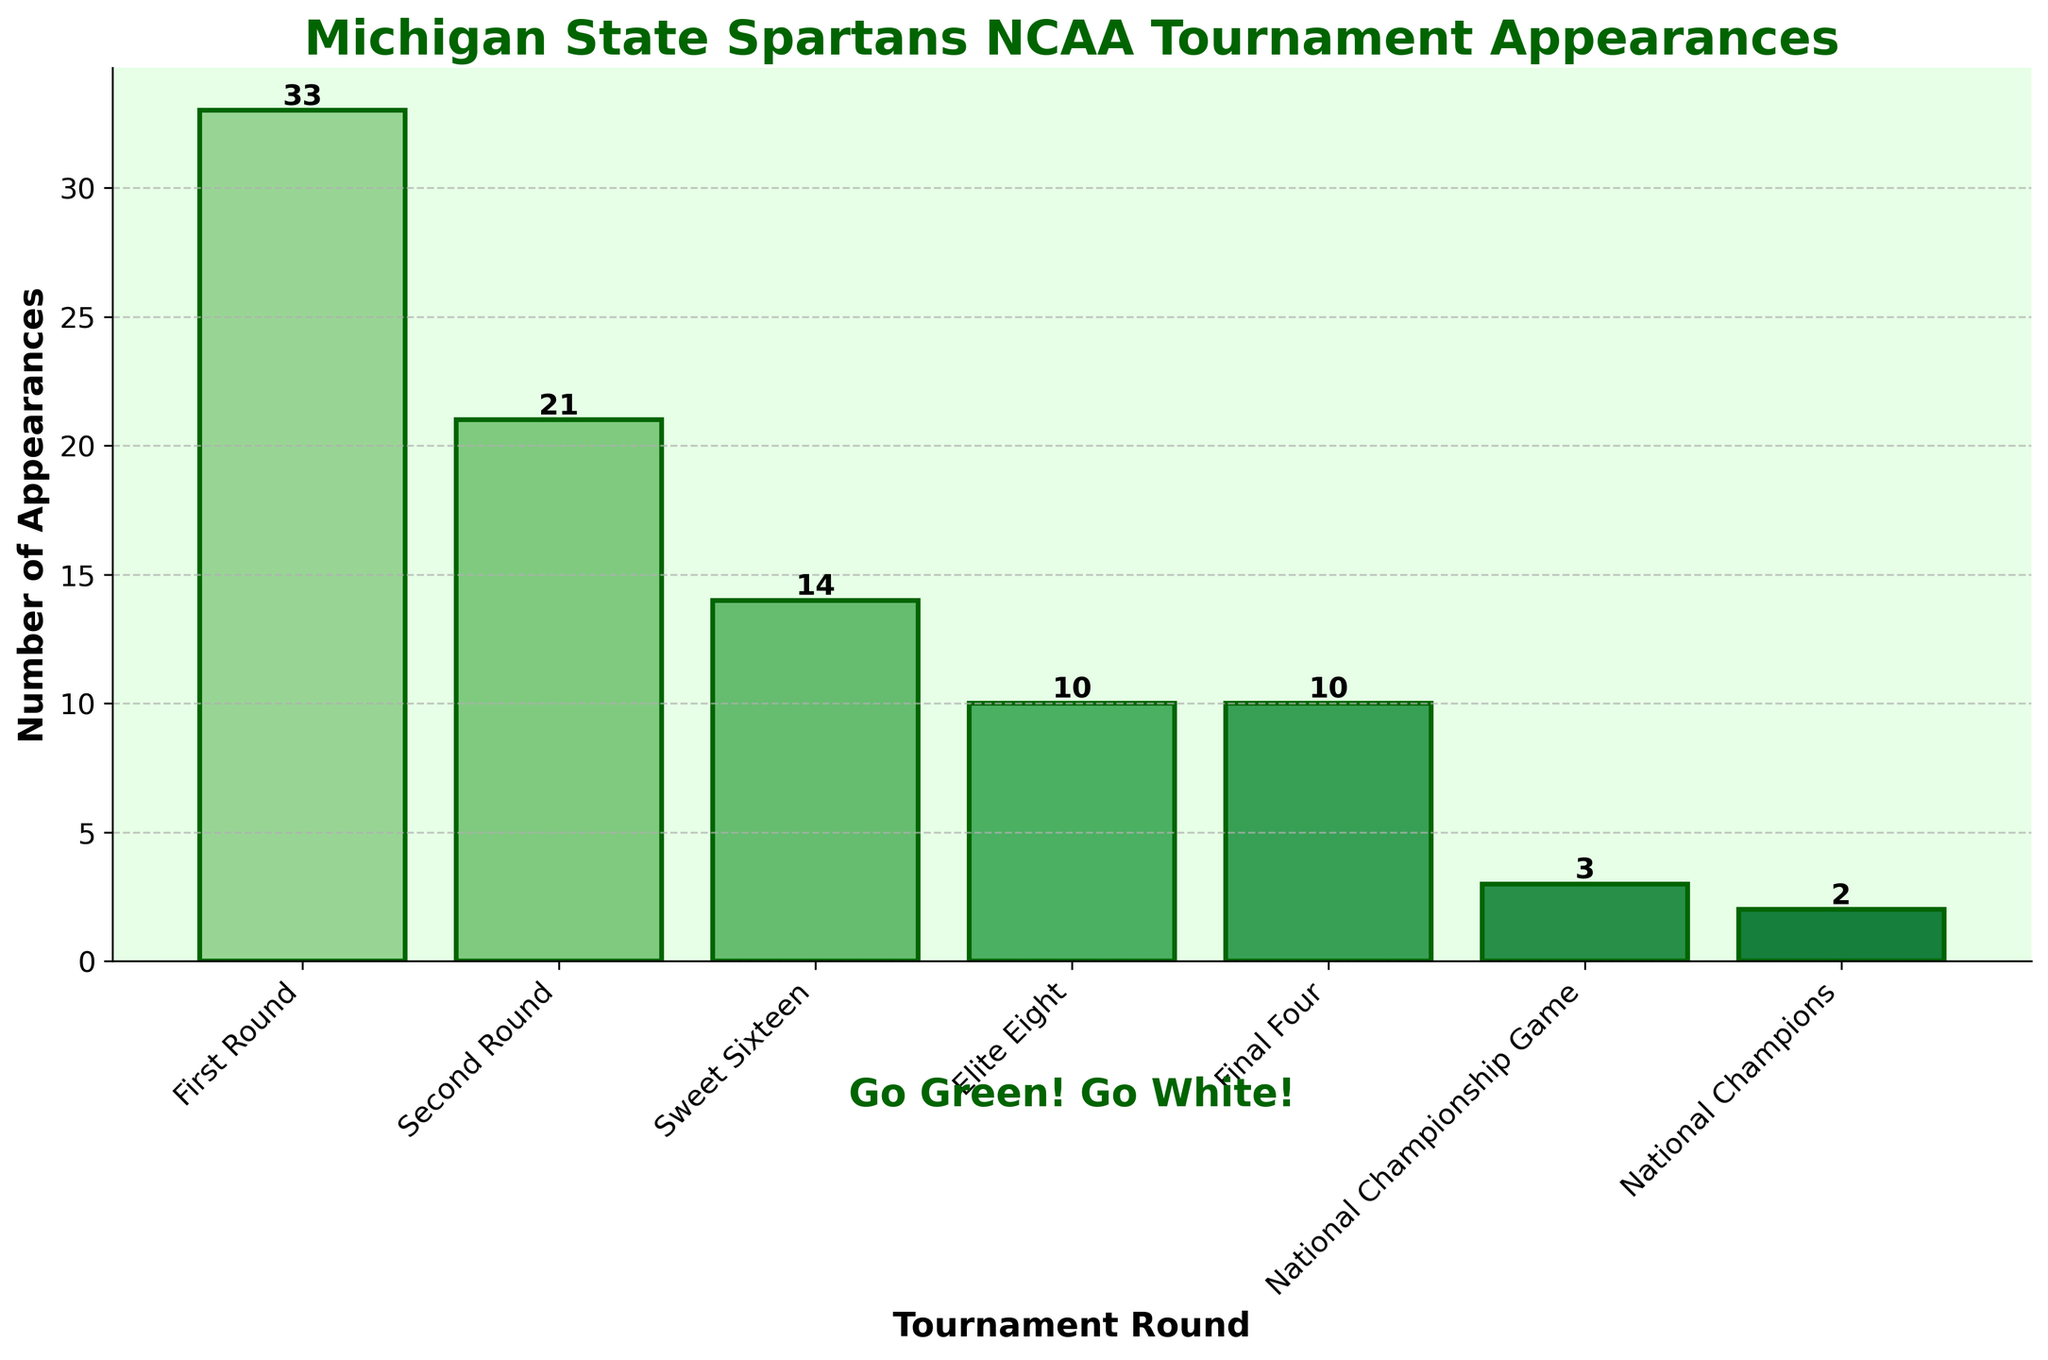Which round has the highest number of appearances? The First Round has the highest number of appearances. This can be determined by visually comparing the heights of all the bars; the bar for the First Round is the tallest.
Answer: First Round How many times has Michigan State reached the National Championship Game? Look at the height of the bar labeled "National Championship Game." The number on top of this bar is 3.
Answer: 3 What is the total number of appearances in the Final Four and Elite Eight combined? Sum the number of appearances for Final Four and Elite Eight. Final Four has 10 appearances and Elite Eight also has 10 appearances. So, 10 + 10 = 20.
Answer: 20 Which is more frequent, appearances in the Sweet Sixteen or the Second Round? Compare the heights of the bars for Sweet Sixteen and Second Round. The Sweet Sixteen bar has a height of 14 while the Second Round bar has a height of 21. Therefore, appearances in the Second Round are more frequent.
Answer: Second Round What is the difference in appearances between the Second Round and National Champions? Subtract the number of National Champions appearances from the Second Round appearances. Second Round has 21 appearances and National Champions has 2 appearances. So, 21 - 2 = 19.
Answer: 19 How many total NCAA tournament appearances does Michigan State have? Sum the appearances for all rounds: 33 (First Round) + 21 (Second Round) + 14 (Sweet Sixteen) + 10 (Elite Eight) + 10 (Final Four) + 3 (National Championship Game) + 2 (National Champions). This equals 93 total appearances.
Answer: 93 What is the ratio of National Championships wins to National Championship Game appearances? Divide the number of National Championship wins by the number of National Championship Game appearances. National Championship wins are 2 and National Championship Game appearances are 3. So, the ratio is 2:3.
Answer: 2:3 How often has Michigan State advanced to the Elite Eight as compared to advancing to the Sweet Sixteen? Divide the number of Elite Eight appearances by the number of Sweet Sixteen appearances. Elite Eight has 10 appearances and Sweet Sixteen has 14 appearances. So, the ratio is 10/14 or approximately 5/7.
Answer: 5/7 Between which two rounds is the difference in appearances the greatest? Subtract the number of appearances of each round from every other. The greatest difference is between the First Round (33) and National Champions (2), with a difference of 33 - 2 = 31.
Answer: First Round and National Champions 